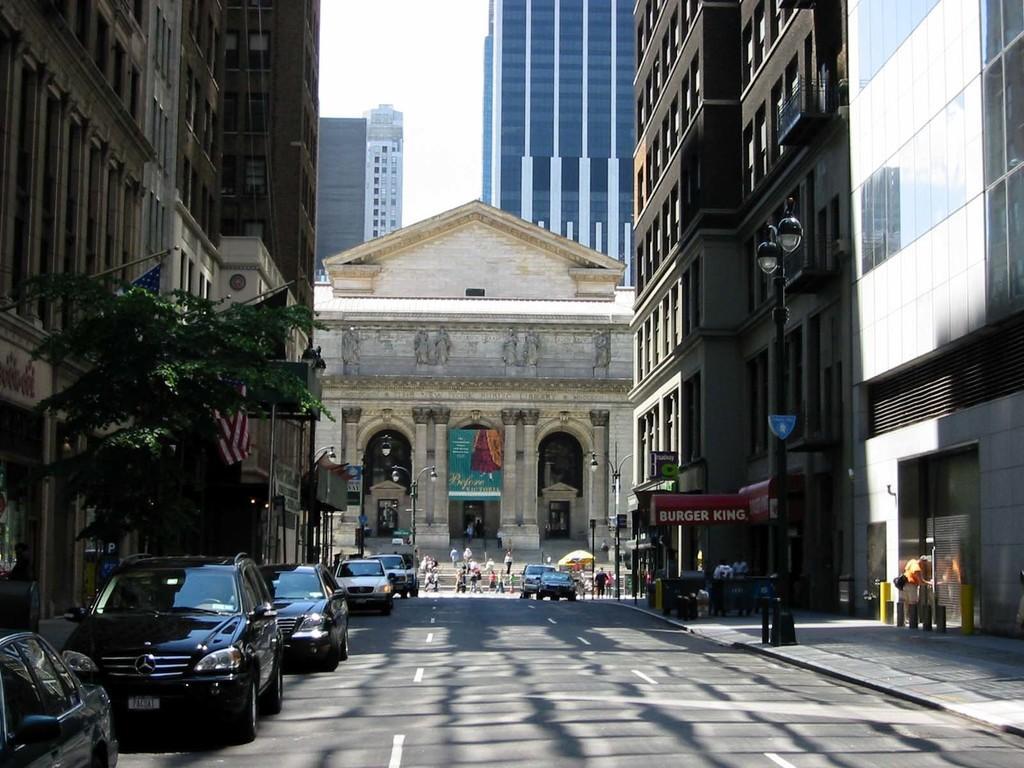How would you summarize this image in a sentence or two? In this image I can see the road. On the road there are many vehicles. To the side of the road I can see the trees, light poles and the buildings. In the back I can see few boards, buildings and the white sky. 